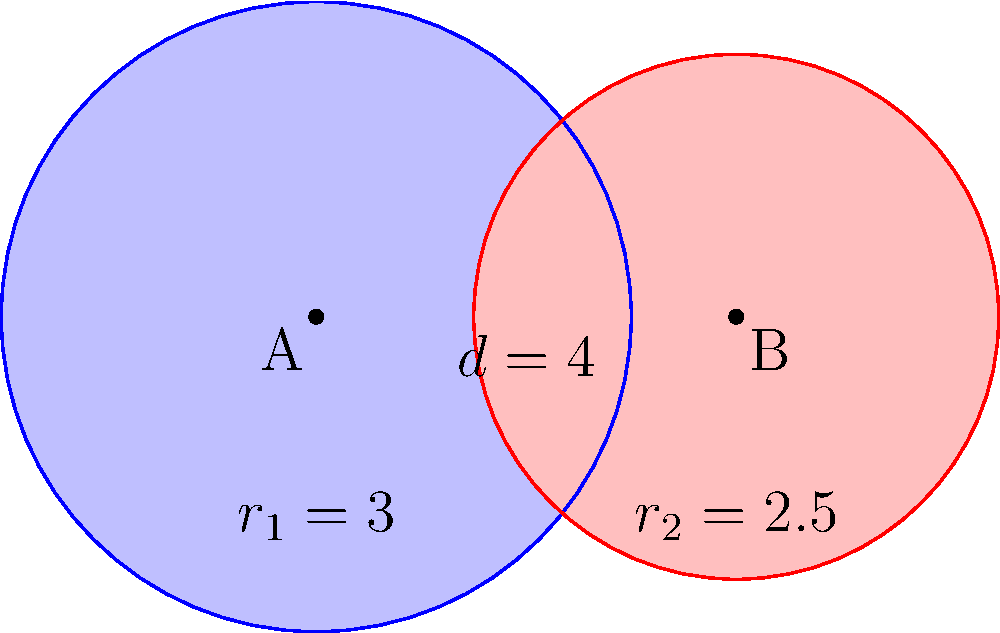In a particle detection experiment, two overlapping circular magnetic fields are generated. The centers of these fields are separated by a distance of 4 units. The radius of the first field is 3 units, and the radius of the second field is 2.5 units. Calculate the area of the overlapping region where both magnetic fields intersect. Express your answer in terms of π. To solve this problem, we'll use the formula for the area of intersection of two circles. Let's approach this step-by-step:

1) First, we need to calculate the distance between the centers of the circles:
   $d = 4$ (given in the problem)

2) We have the radii:
   $r_1 = 3$ and $r_2 = 2.5$

3) Now, we need to calculate the angles $\theta_1$ and $\theta_2$ using the law of cosines:

   $\cos(\theta_1/2) = \frac{d^2 + r_1^2 - r_2^2}{2dr_1}$
   $\cos(\theta_1/2) = \frac{4^2 + 3^2 - 2.5^2}{2(4)(3)} = 0.7291667$
   $\theta_1 = 2 \arccos(0.7291667) = 1.5904 \text{ radians}$

   $\cos(\theta_2/2) = \frac{d^2 + r_2^2 - r_1^2}{2dr_2}$
   $\cos(\theta_2/2) = \frac{4^2 + 2.5^2 - 3^2}{2(4)(2.5)} = 0.6750000$
   $\theta_2 = 2 \arccos(0.6750000) = 1.7249 \text{ radians}$

4) The area of intersection is given by:
   $A = r_1^2 (\frac{\theta_1}{2} - \frac{\sin(\theta_1)}{2}) + r_2^2 (\frac{\theta_2}{2} - \frac{\sin(\theta_2)}{2})$

5) Substituting the values:
   $A = 3^2 (\frac{1.5904}{2} - \frac{\sin(1.5904)}{2}) + 2.5^2 (\frac{1.7249}{2} - \frac{\sin(1.7249)}{2})$
   $A = 9 (0.7952 - 0.7044) + 6.25 (0.8625 - 0.7778)$
   $A = 9(0.0908) + 6.25(0.0847)$
   $A = 0.8172 + 0.5294$
   $A = 1.3466$

6) Therefore, the area of intersection is approximately 1.3466 square units.

7) To express this in terms of π, we divide by π:
   $\frac{1.3466}{\pi} \approx 0.4286$

Thus, the area of intersection is approximately $\frac{0.4286\pi}{\pi} = 0.4286\pi$ square units.
Answer: $0.4286\pi$ square units 